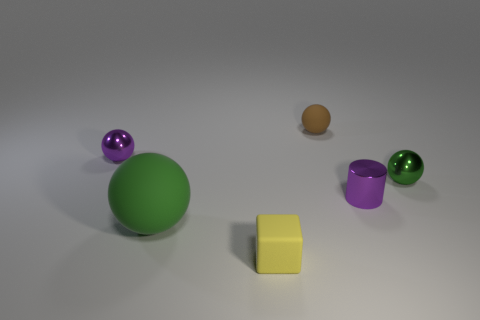There is a tiny rubber thing that is in front of the tiny cylinder; is it the same color as the matte ball that is on the left side of the tiny rubber cube?
Your answer should be very brief. No. What number of other things are there of the same material as the block
Provide a short and direct response. 2. There is a rubber object that is behind the tiny yellow matte block and to the right of the green rubber object; what is its shape?
Provide a short and direct response. Sphere. There is a tiny cube; is it the same color as the tiny sphere that is right of the cylinder?
Provide a succinct answer. No. Do the purple metallic thing that is on the right side of the purple sphere and the big green rubber sphere have the same size?
Your answer should be compact. No. There is a big green thing that is the same shape as the brown rubber thing; what material is it?
Give a very brief answer. Rubber. Is the big object the same shape as the yellow object?
Make the answer very short. No. There is a green object on the right side of the big rubber thing; what number of green objects are in front of it?
Provide a short and direct response. 1. The other small object that is the same material as the brown object is what shape?
Provide a succinct answer. Cube. What number of red objects are tiny shiny balls or matte spheres?
Ensure brevity in your answer.  0. 